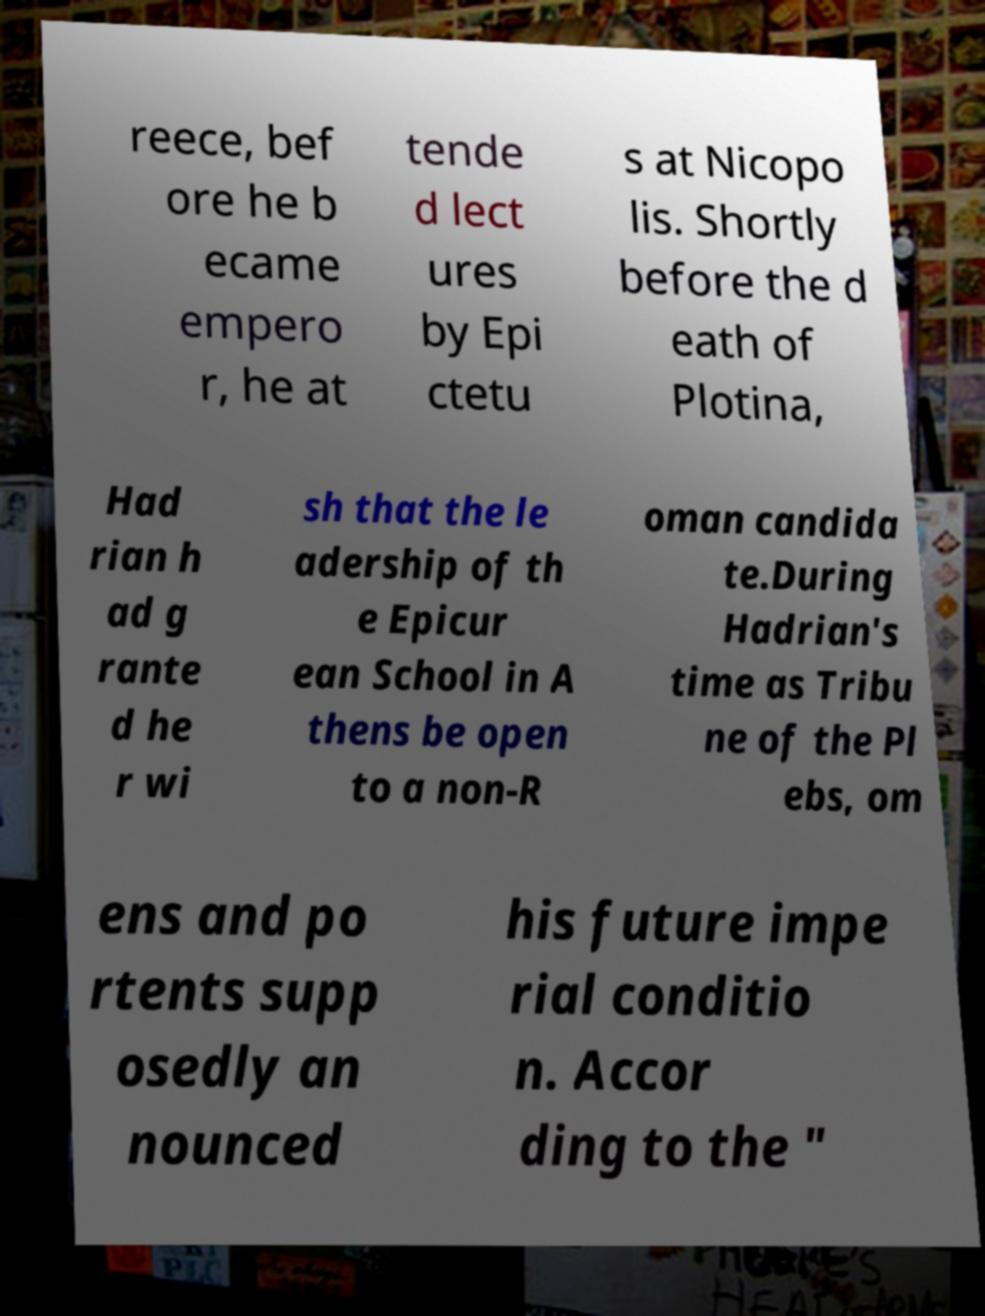I need the written content from this picture converted into text. Can you do that? reece, bef ore he b ecame empero r, he at tende d lect ures by Epi ctetu s at Nicopo lis. Shortly before the d eath of Plotina, Had rian h ad g rante d he r wi sh that the le adership of th e Epicur ean School in A thens be open to a non-R oman candida te.During Hadrian's time as Tribu ne of the Pl ebs, om ens and po rtents supp osedly an nounced his future impe rial conditio n. Accor ding to the " 